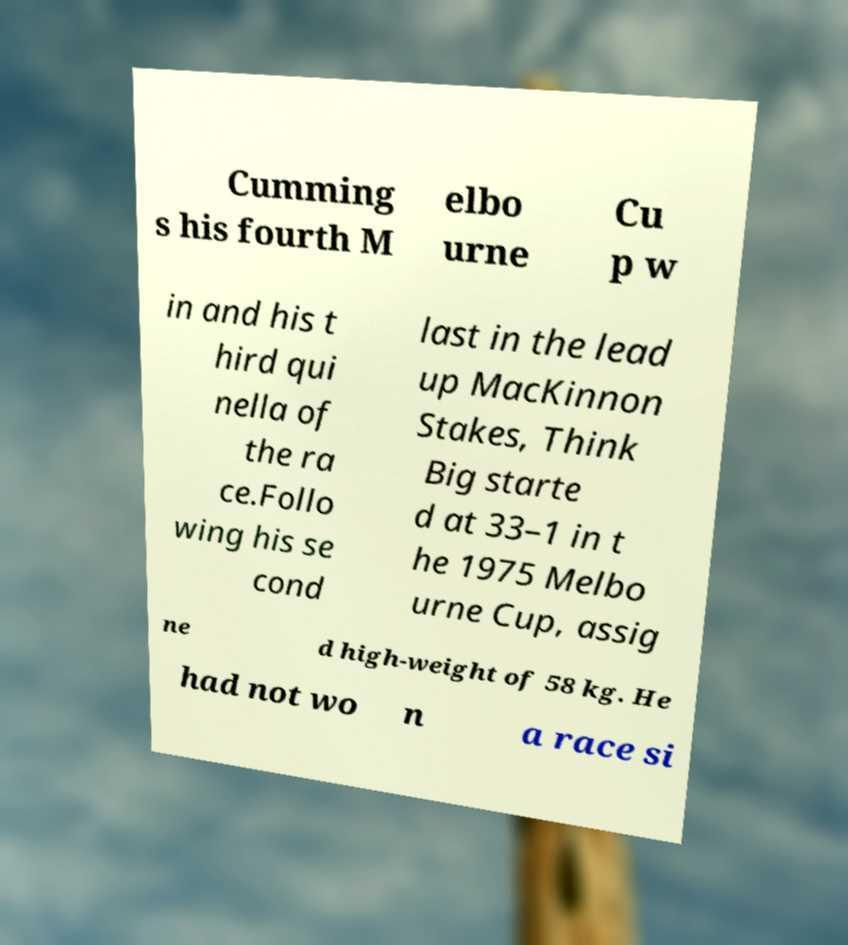I need the written content from this picture converted into text. Can you do that? Cumming s his fourth M elbo urne Cu p w in and his t hird qui nella of the ra ce.Follo wing his se cond last in the lead up MacKinnon Stakes, Think Big starte d at 33–1 in t he 1975 Melbo urne Cup, assig ne d high-weight of 58 kg. He had not wo n a race si 